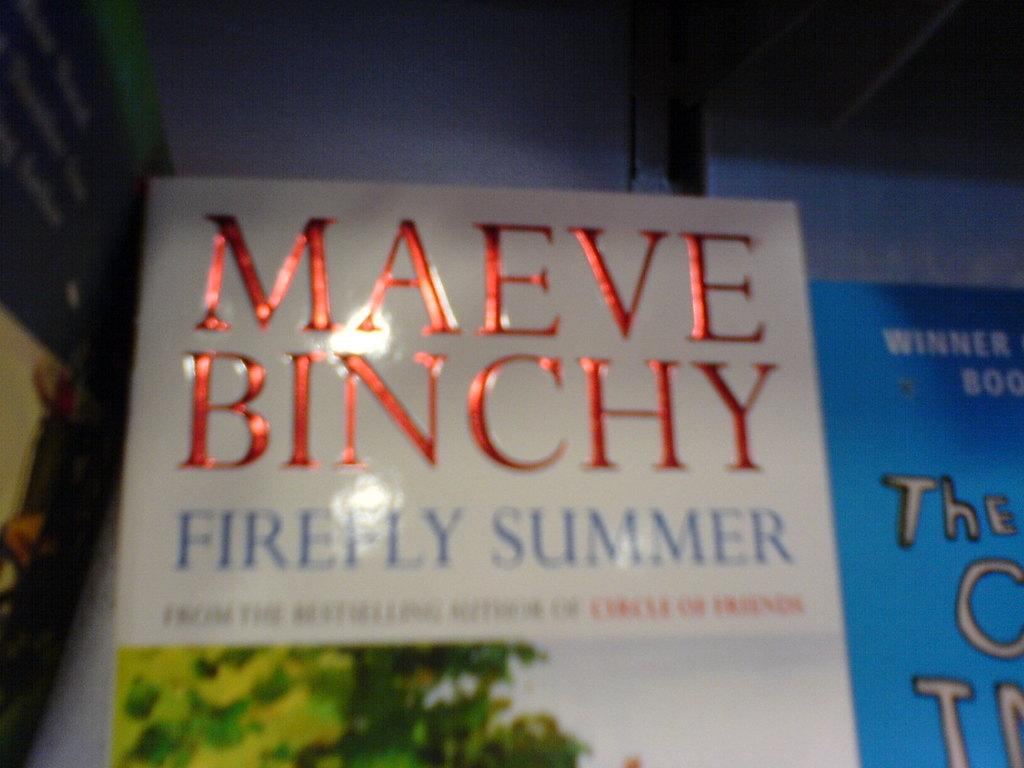<image>
Provide a brief description of the given image. A book called Firefly Summer by Maeve Binchy. 